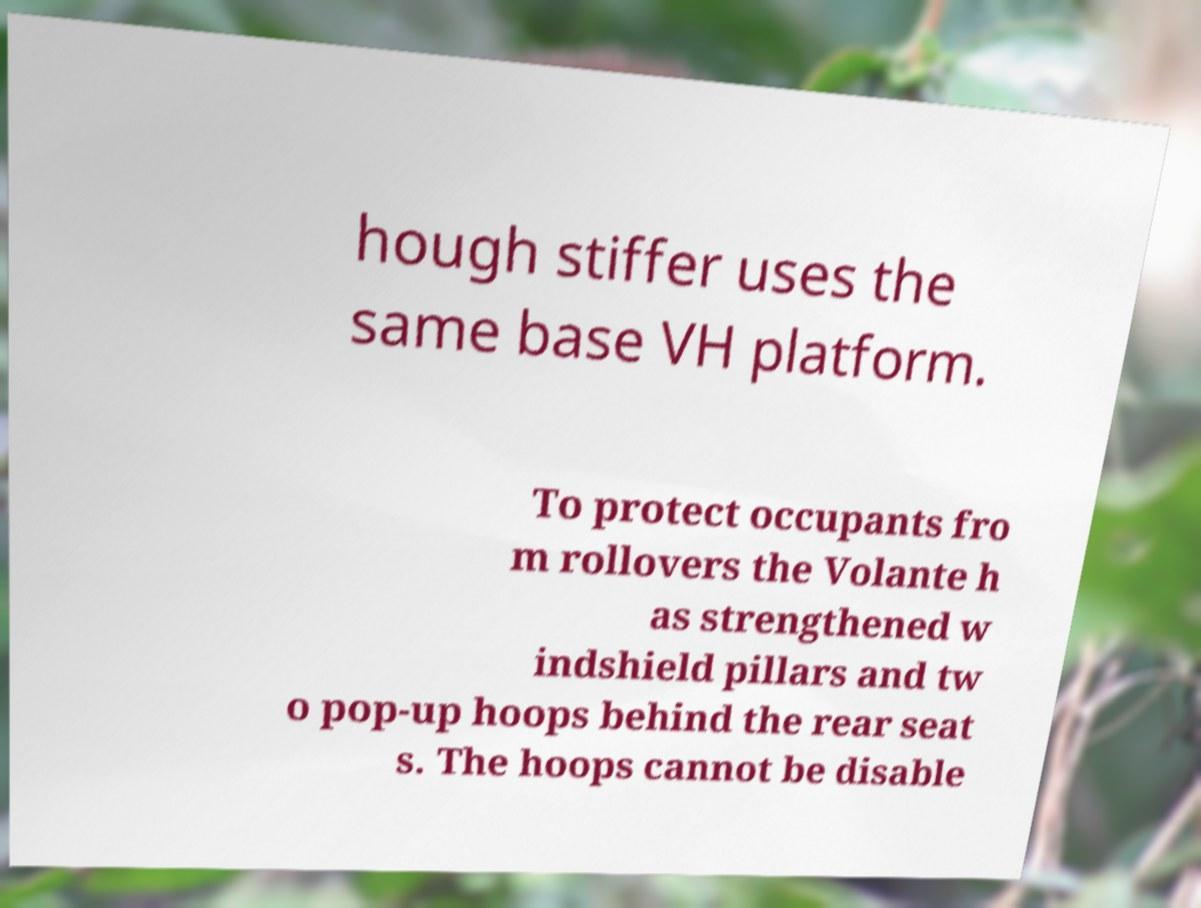Please read and relay the text visible in this image. What does it say? hough stiffer uses the same base VH platform. To protect occupants fro m rollovers the Volante h as strengthened w indshield pillars and tw o pop-up hoops behind the rear seat s. The hoops cannot be disable 